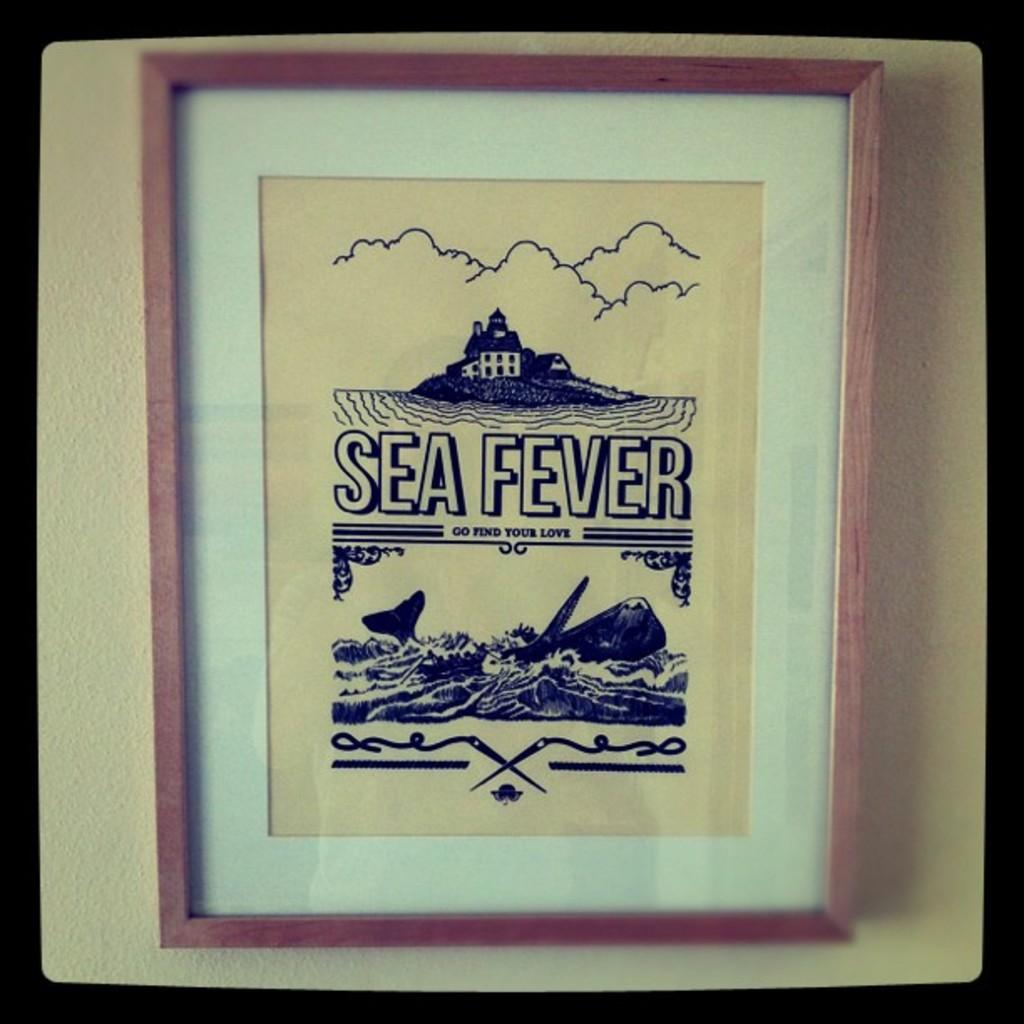<image>
Create a compact narrative representing the image presented. A framed and matted picture reads Sea Fever and Go find your love. 